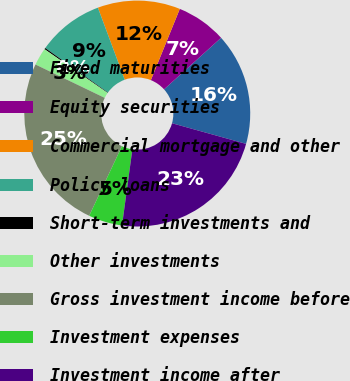Convert chart to OTSL. <chart><loc_0><loc_0><loc_500><loc_500><pie_chart><fcel>Fixed maturities<fcel>Equity securities<fcel>Commercial mortgage and other<fcel>Policy loans<fcel>Short-term investments and<fcel>Other investments<fcel>Gross investment income before<fcel>Investment expenses<fcel>Investment income after<nl><fcel>16.02%<fcel>7.16%<fcel>11.81%<fcel>9.49%<fcel>0.19%<fcel>2.51%<fcel>25.15%<fcel>4.84%<fcel>22.83%<nl></chart> 